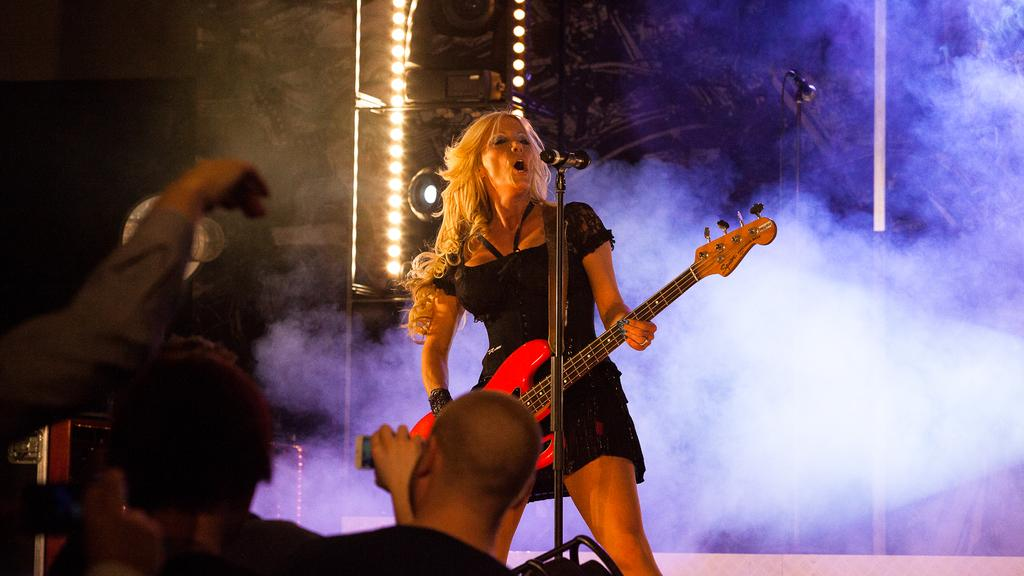What is the person holding in the image? The person is holding a guitar. What is the person doing with the guitar? The person is singing while holding the guitar. Who is present in the image besides the person with the guitar? There is an audience present in the image. What is the person using to amplify their voice? There is a microphone with a stand in the image. What can be seen in the background of the image? Lights and smoke are visible in the background. What statement does the person's sister make about the river in the image? There is no mention of a sister or a river in the image, so it is not possible to answer that question. 